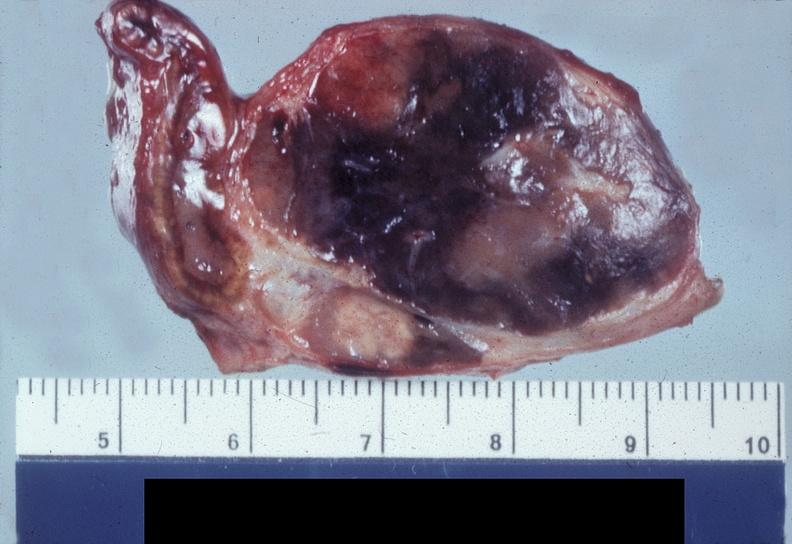does cachexia show adrenal, pheochromocytoma?
Answer the question using a single word or phrase. No 